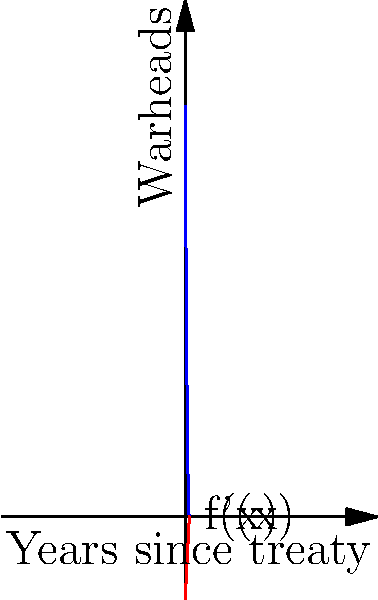The function $f(x) = 1000 - 200x + 10x^2$ models the number of nuclear warheads remaining $x$ years after a hypothetical U.S.-Russia arms reduction treaty is signed. What is the rate of change in the number of warheads 5 years after the treaty is signed? How does this relate to the effectiveness of the treaty at that point? To solve this problem, we need to follow these steps:

1) First, we need to find the derivative of the function $f(x)$:
   $f(x) = 1000 - 200x + 10x^2$
   $f'(x) = -200 + 20x$

2) The question asks for the rate of change 5 years after the treaty is signed, so we need to evaluate $f'(5)$:
   $f'(5) = -200 + 20(5) = -200 + 100 = -100$

3) Interpretation:
   The negative value indicates that the number of warheads is decreasing.
   The rate of change is -100 warheads per year at the 5-year mark.

4) Regarding the effectiveness of the treaty:
   The treaty initially reduces warheads quickly (when x is small, f'(x) is more negative).
   At x = 5, the rate of reduction is slowing down but still significant.
   The positive coefficient of $x^2$ in $f(x)$ suggests the treaty becomes less effective over time.
Answer: -100 warheads per year; treaty effectiveness is decreasing but still significant 